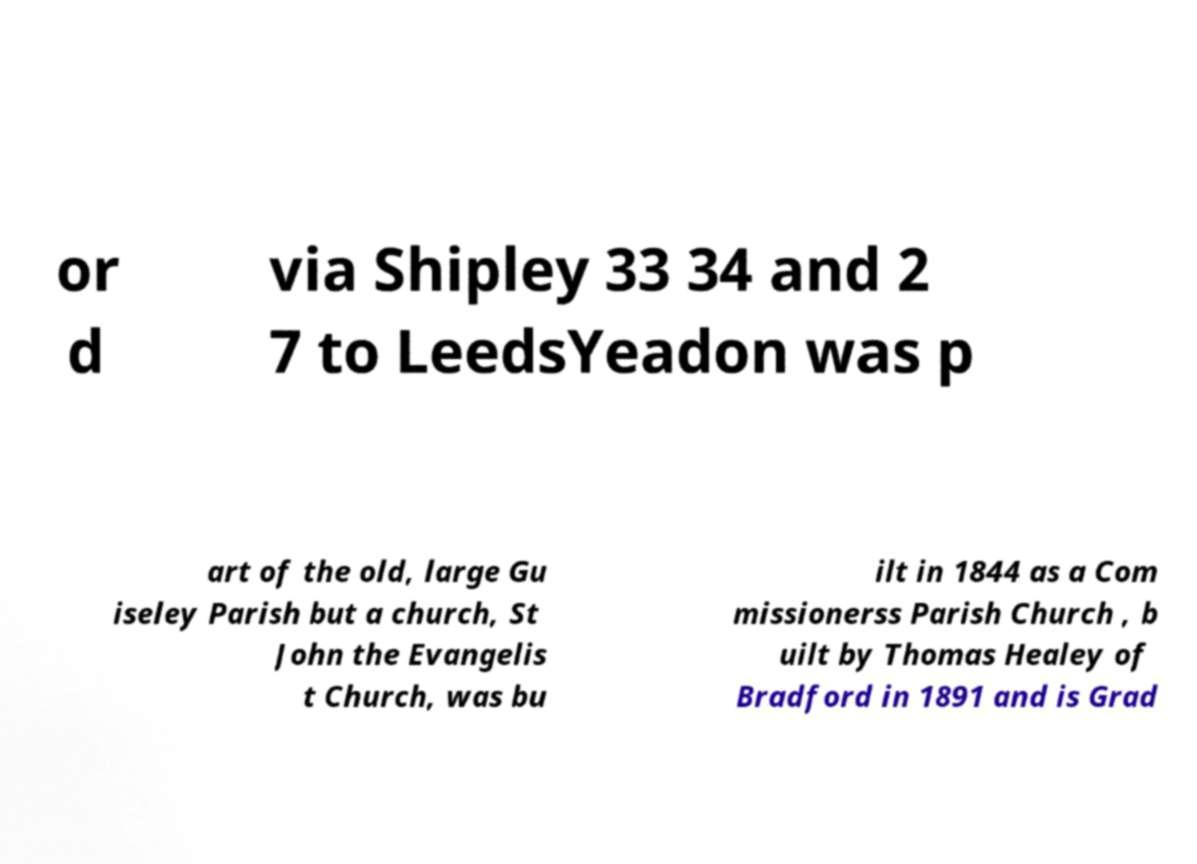Can you accurately transcribe the text from the provided image for me? or d via Shipley 33 34 and 2 7 to LeedsYeadon was p art of the old, large Gu iseley Parish but a church, St John the Evangelis t Church, was bu ilt in 1844 as a Com missionerss Parish Church , b uilt by Thomas Healey of Bradford in 1891 and is Grad 